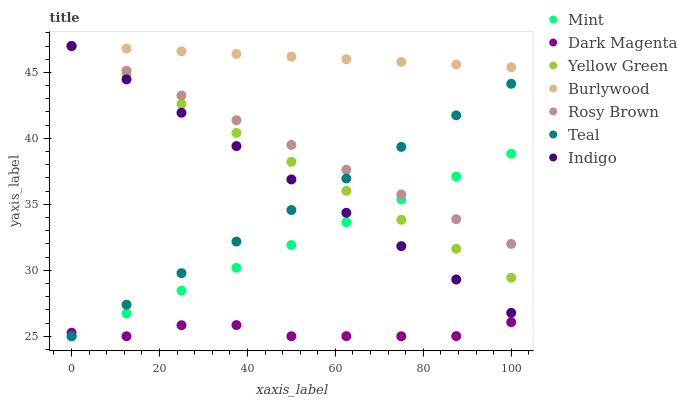Does Dark Magenta have the minimum area under the curve?
Answer yes or no. Yes. Does Burlywood have the maximum area under the curve?
Answer yes or no. Yes. Does Burlywood have the minimum area under the curve?
Answer yes or no. No. Does Dark Magenta have the maximum area under the curve?
Answer yes or no. No. Is Rosy Brown the smoothest?
Answer yes or no. Yes. Is Dark Magenta the roughest?
Answer yes or no. Yes. Is Burlywood the smoothest?
Answer yes or no. No. Is Burlywood the roughest?
Answer yes or no. No. Does Dark Magenta have the lowest value?
Answer yes or no. Yes. Does Burlywood have the lowest value?
Answer yes or no. No. Does Yellow Green have the highest value?
Answer yes or no. Yes. Does Dark Magenta have the highest value?
Answer yes or no. No. Is Dark Magenta less than Indigo?
Answer yes or no. Yes. Is Rosy Brown greater than Dark Magenta?
Answer yes or no. Yes. Does Indigo intersect Burlywood?
Answer yes or no. Yes. Is Indigo less than Burlywood?
Answer yes or no. No. Is Indigo greater than Burlywood?
Answer yes or no. No. Does Dark Magenta intersect Indigo?
Answer yes or no. No. 